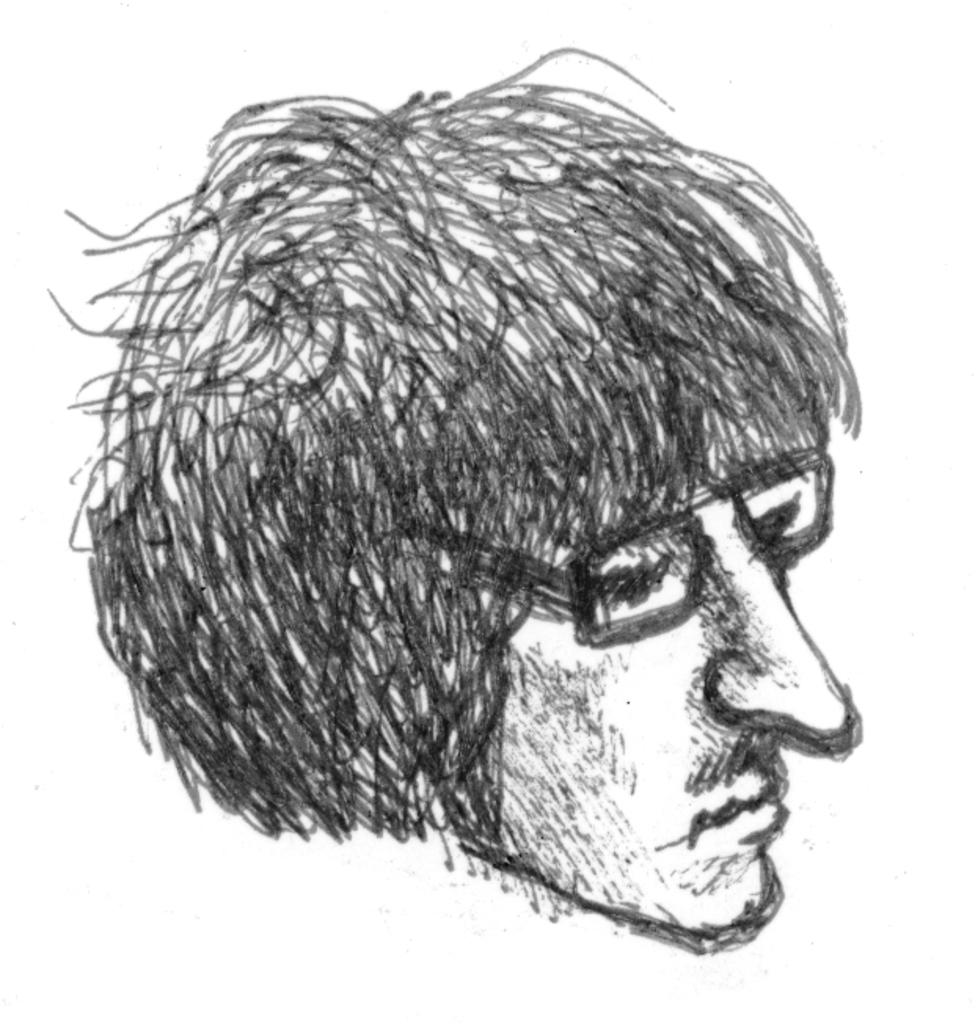What type of artwork is depicted in the image? There is a pencil drawing in the image. What subject is the drawing focused on? The drawing is of a person's face. What type of pain is the person in the drawing experiencing? There is no indication in the image that the person in the drawing is experiencing any pain. What type of quilt is visible in the image? There is no quilt present in the image; it features a pencil drawing of a person's face. 